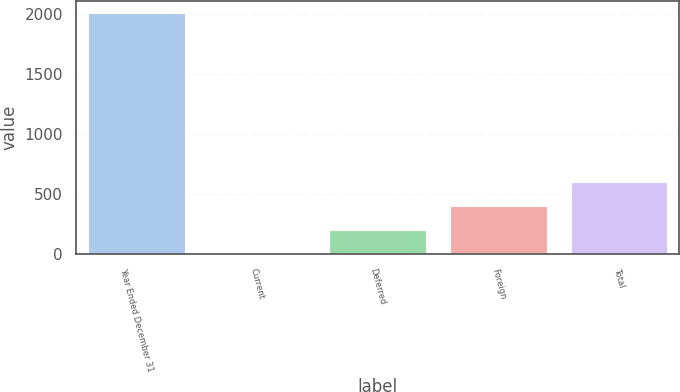Convert chart to OTSL. <chart><loc_0><loc_0><loc_500><loc_500><bar_chart><fcel>Year Ended December 31<fcel>Current<fcel>Deferred<fcel>Foreign<fcel>Total<nl><fcel>2009<fcel>3<fcel>203.6<fcel>404.2<fcel>604.8<nl></chart> 